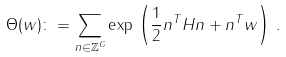Convert formula to latex. <formula><loc_0><loc_0><loc_500><loc_500>\Theta ( { w } ) \colon = \sum _ { { n } \in { \mathbb { Z } } ^ { G } } \exp \, \left ( \frac { 1 } { 2 } { n } ^ { T } { H n } + { n } ^ { T } { w } \right ) \, .</formula> 